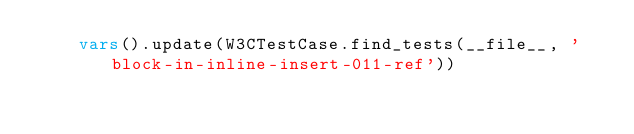<code> <loc_0><loc_0><loc_500><loc_500><_Python_>    vars().update(W3CTestCase.find_tests(__file__, 'block-in-inline-insert-011-ref'))
</code> 